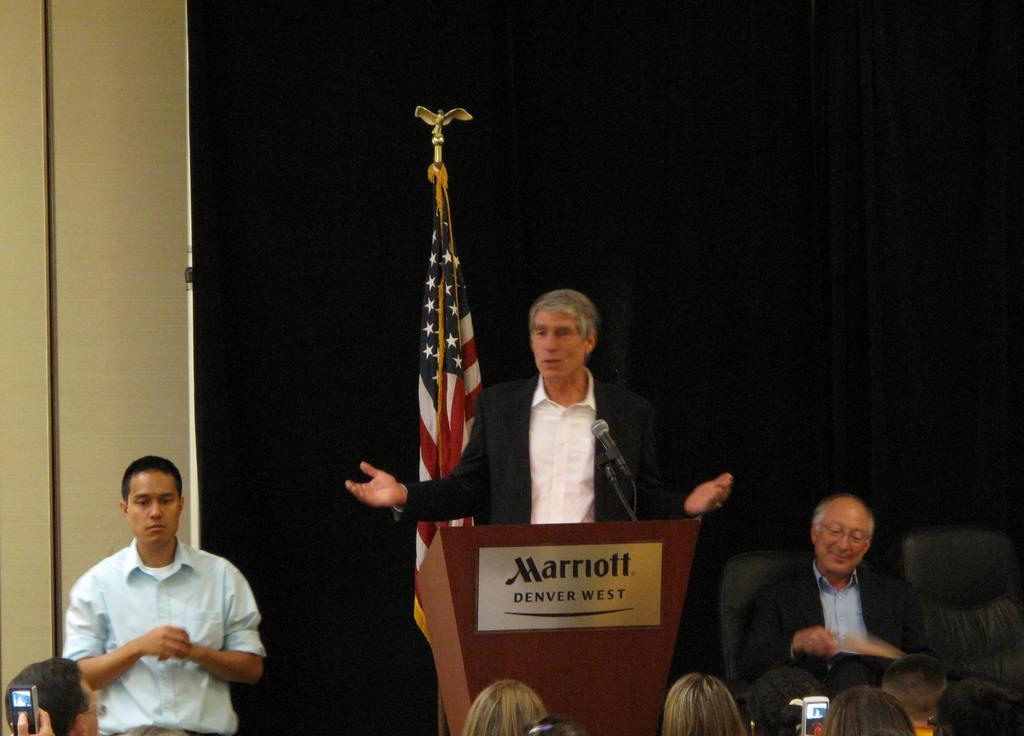Can you describe this image briefly? In this picture we can see mobiles, flag, podium, mic, chairs, black curtain, wall and a group of people where a man sitting and two men are standing. 